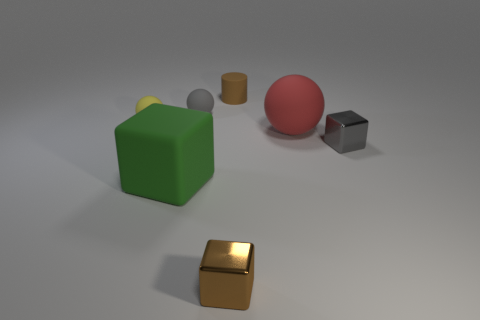Are there the same number of brown objects that are in front of the gray matte ball and red things?
Make the answer very short. Yes. Is there a tiny object of the same color as the tiny matte cylinder?
Your response must be concise. Yes. Do the red matte object and the gray sphere have the same size?
Provide a succinct answer. No. There is a brown thing on the left side of the brown thing behind the gray rubber thing; how big is it?
Your answer should be very brief. Small. What is the size of the matte thing that is on the right side of the tiny gray ball and on the left side of the red thing?
Offer a very short reply. Small. What number of brown objects have the same size as the cylinder?
Keep it short and to the point. 1. How many matte objects are large gray things or small gray blocks?
Make the answer very short. 0. The object that is the same color as the small matte cylinder is what size?
Your response must be concise. Small. What is the material of the small cube that is in front of the block that is behind the green rubber block?
Provide a succinct answer. Metal. How many things are green blocks or small objects that are left of the big red ball?
Offer a terse response. 5. 